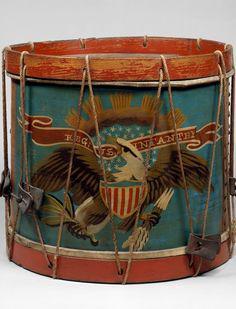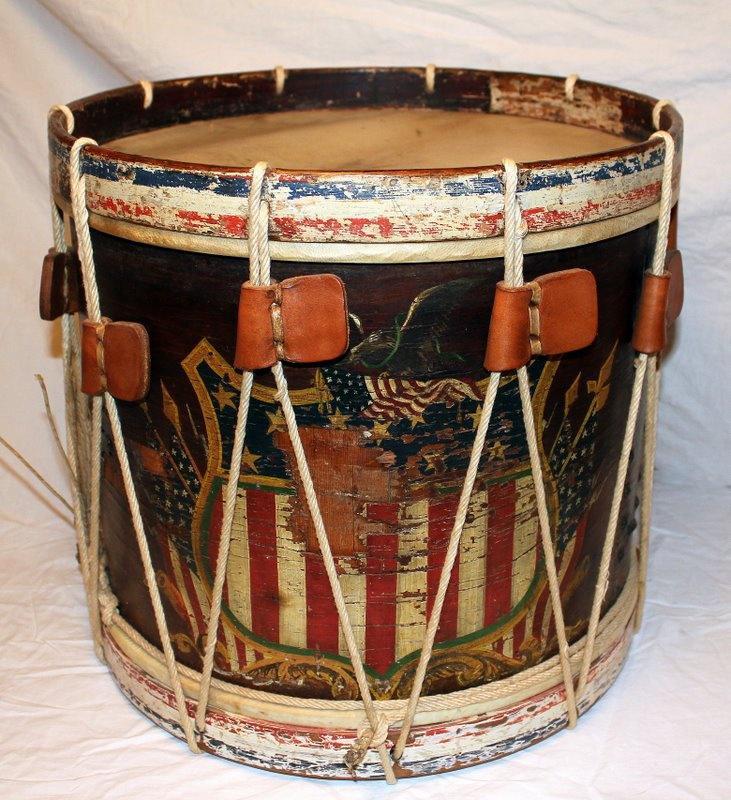The first image is the image on the left, the second image is the image on the right. Evaluate the accuracy of this statement regarding the images: "There is more than one type of instrument.". Is it true? Answer yes or no. No. The first image is the image on the left, the second image is the image on the right. Evaluate the accuracy of this statement regarding the images: "One image shows a single drum while the other shows drums along with other types of instruments.". Is it true? Answer yes or no. No. 